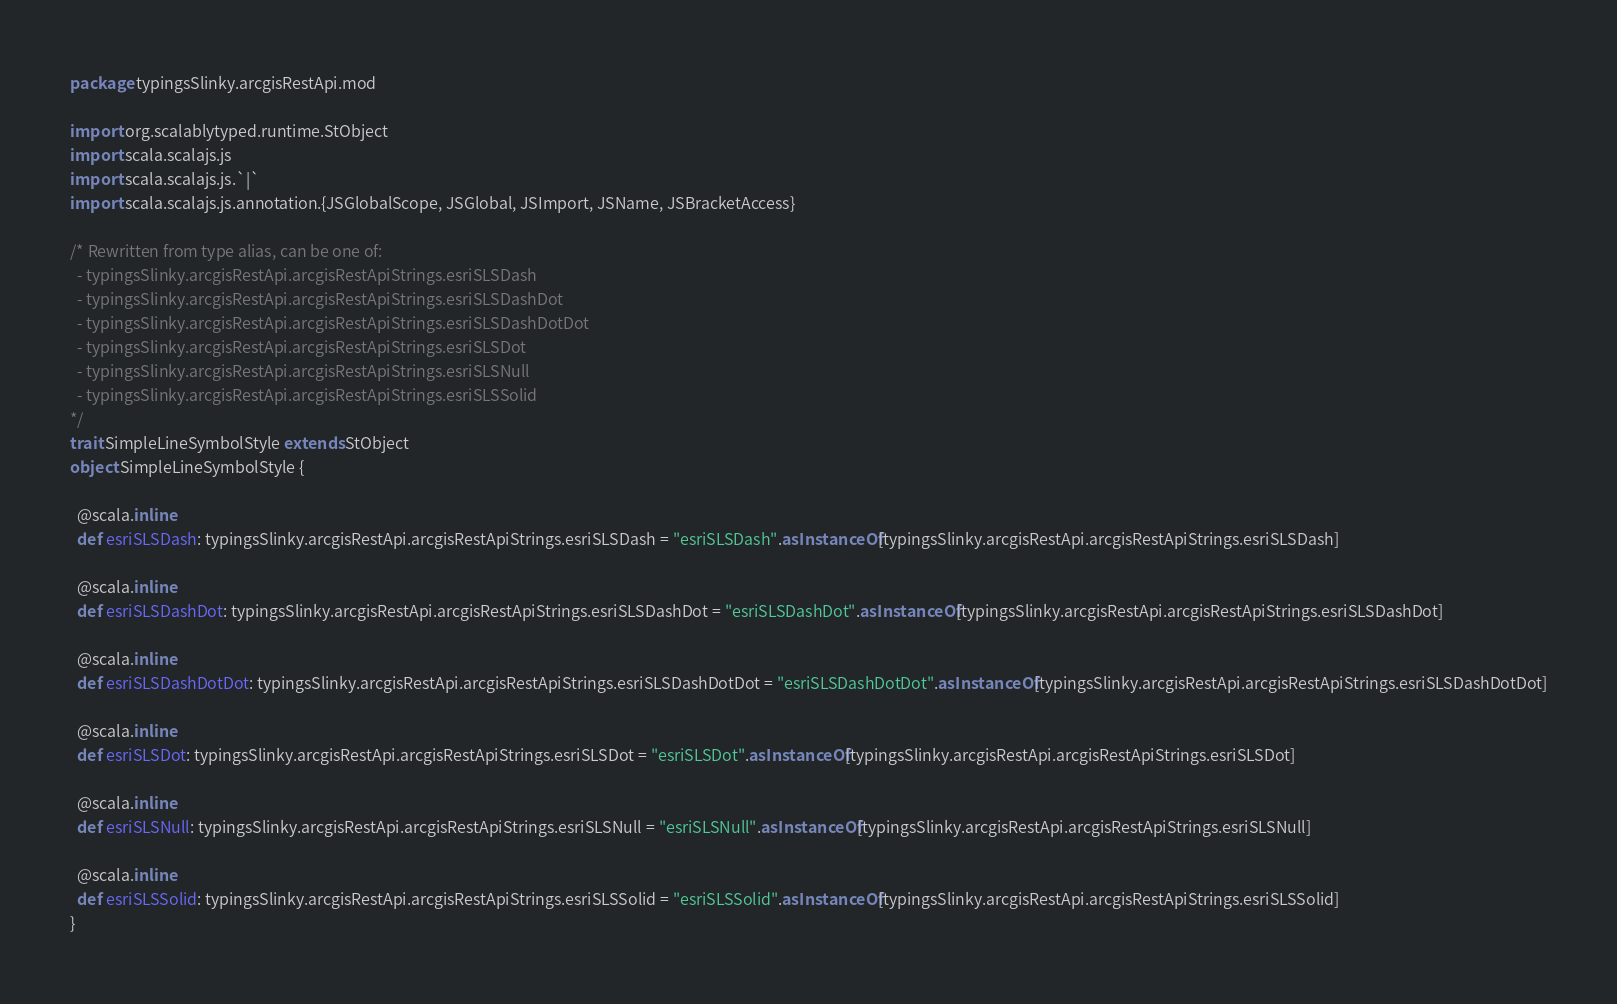<code> <loc_0><loc_0><loc_500><loc_500><_Scala_>package typingsSlinky.arcgisRestApi.mod

import org.scalablytyped.runtime.StObject
import scala.scalajs.js
import scala.scalajs.js.`|`
import scala.scalajs.js.annotation.{JSGlobalScope, JSGlobal, JSImport, JSName, JSBracketAccess}

/* Rewritten from type alias, can be one of: 
  - typingsSlinky.arcgisRestApi.arcgisRestApiStrings.esriSLSDash
  - typingsSlinky.arcgisRestApi.arcgisRestApiStrings.esriSLSDashDot
  - typingsSlinky.arcgisRestApi.arcgisRestApiStrings.esriSLSDashDotDot
  - typingsSlinky.arcgisRestApi.arcgisRestApiStrings.esriSLSDot
  - typingsSlinky.arcgisRestApi.arcgisRestApiStrings.esriSLSNull
  - typingsSlinky.arcgisRestApi.arcgisRestApiStrings.esriSLSSolid
*/
trait SimpleLineSymbolStyle extends StObject
object SimpleLineSymbolStyle {
  
  @scala.inline
  def esriSLSDash: typingsSlinky.arcgisRestApi.arcgisRestApiStrings.esriSLSDash = "esriSLSDash".asInstanceOf[typingsSlinky.arcgisRestApi.arcgisRestApiStrings.esriSLSDash]
  
  @scala.inline
  def esriSLSDashDot: typingsSlinky.arcgisRestApi.arcgisRestApiStrings.esriSLSDashDot = "esriSLSDashDot".asInstanceOf[typingsSlinky.arcgisRestApi.arcgisRestApiStrings.esriSLSDashDot]
  
  @scala.inline
  def esriSLSDashDotDot: typingsSlinky.arcgisRestApi.arcgisRestApiStrings.esriSLSDashDotDot = "esriSLSDashDotDot".asInstanceOf[typingsSlinky.arcgisRestApi.arcgisRestApiStrings.esriSLSDashDotDot]
  
  @scala.inline
  def esriSLSDot: typingsSlinky.arcgisRestApi.arcgisRestApiStrings.esriSLSDot = "esriSLSDot".asInstanceOf[typingsSlinky.arcgisRestApi.arcgisRestApiStrings.esriSLSDot]
  
  @scala.inline
  def esriSLSNull: typingsSlinky.arcgisRestApi.arcgisRestApiStrings.esriSLSNull = "esriSLSNull".asInstanceOf[typingsSlinky.arcgisRestApi.arcgisRestApiStrings.esriSLSNull]
  
  @scala.inline
  def esriSLSSolid: typingsSlinky.arcgisRestApi.arcgisRestApiStrings.esriSLSSolid = "esriSLSSolid".asInstanceOf[typingsSlinky.arcgisRestApi.arcgisRestApiStrings.esriSLSSolid]
}
</code> 